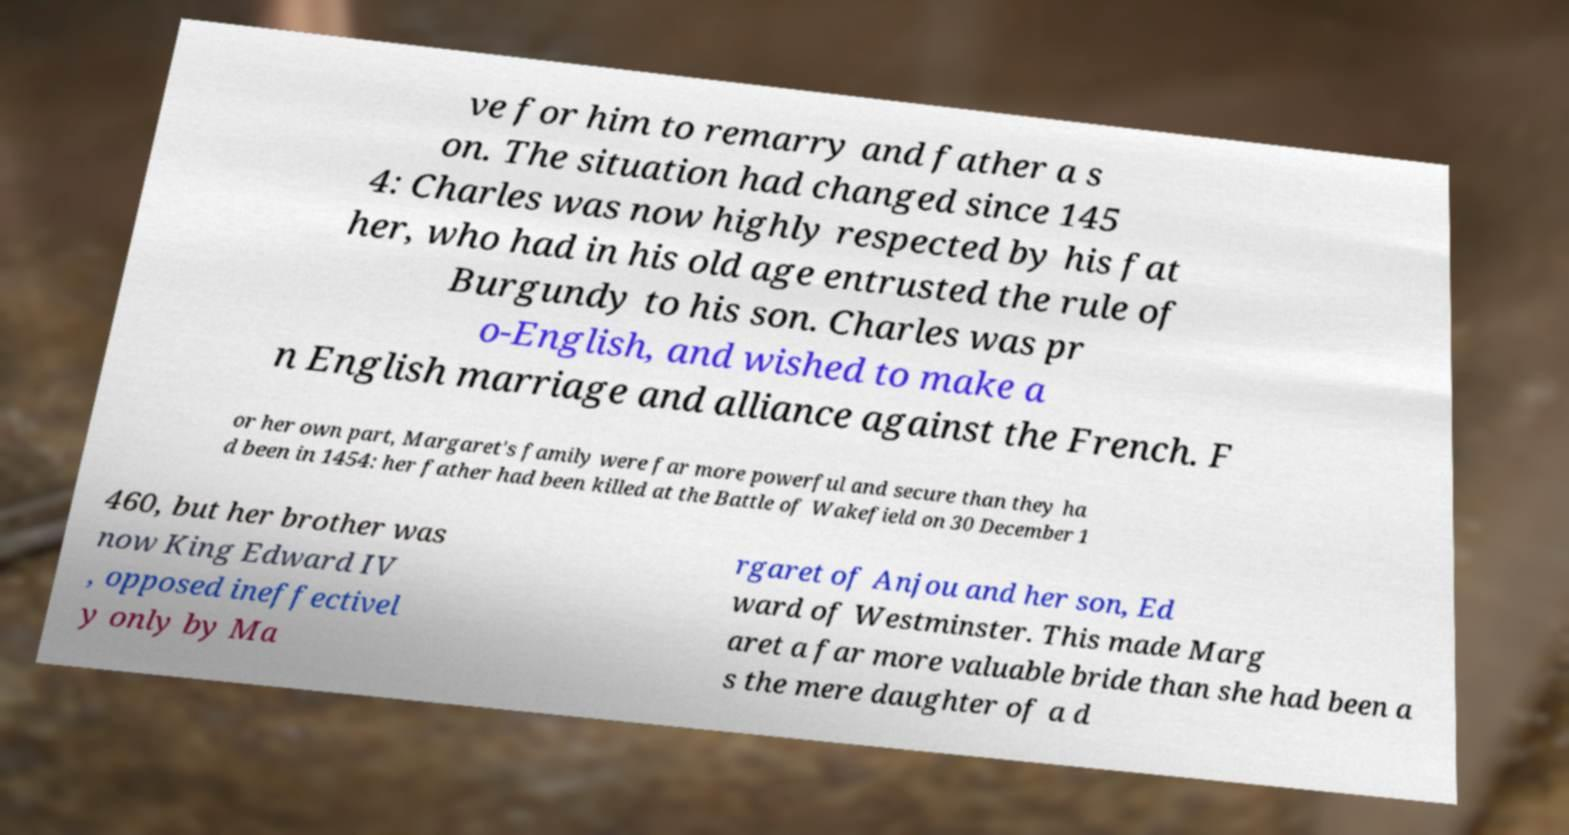I need the written content from this picture converted into text. Can you do that? ve for him to remarry and father a s on. The situation had changed since 145 4: Charles was now highly respected by his fat her, who had in his old age entrusted the rule of Burgundy to his son. Charles was pr o-English, and wished to make a n English marriage and alliance against the French. F or her own part, Margaret's family were far more powerful and secure than they ha d been in 1454: her father had been killed at the Battle of Wakefield on 30 December 1 460, but her brother was now King Edward IV , opposed ineffectivel y only by Ma rgaret of Anjou and her son, Ed ward of Westminster. This made Marg aret a far more valuable bride than she had been a s the mere daughter of a d 